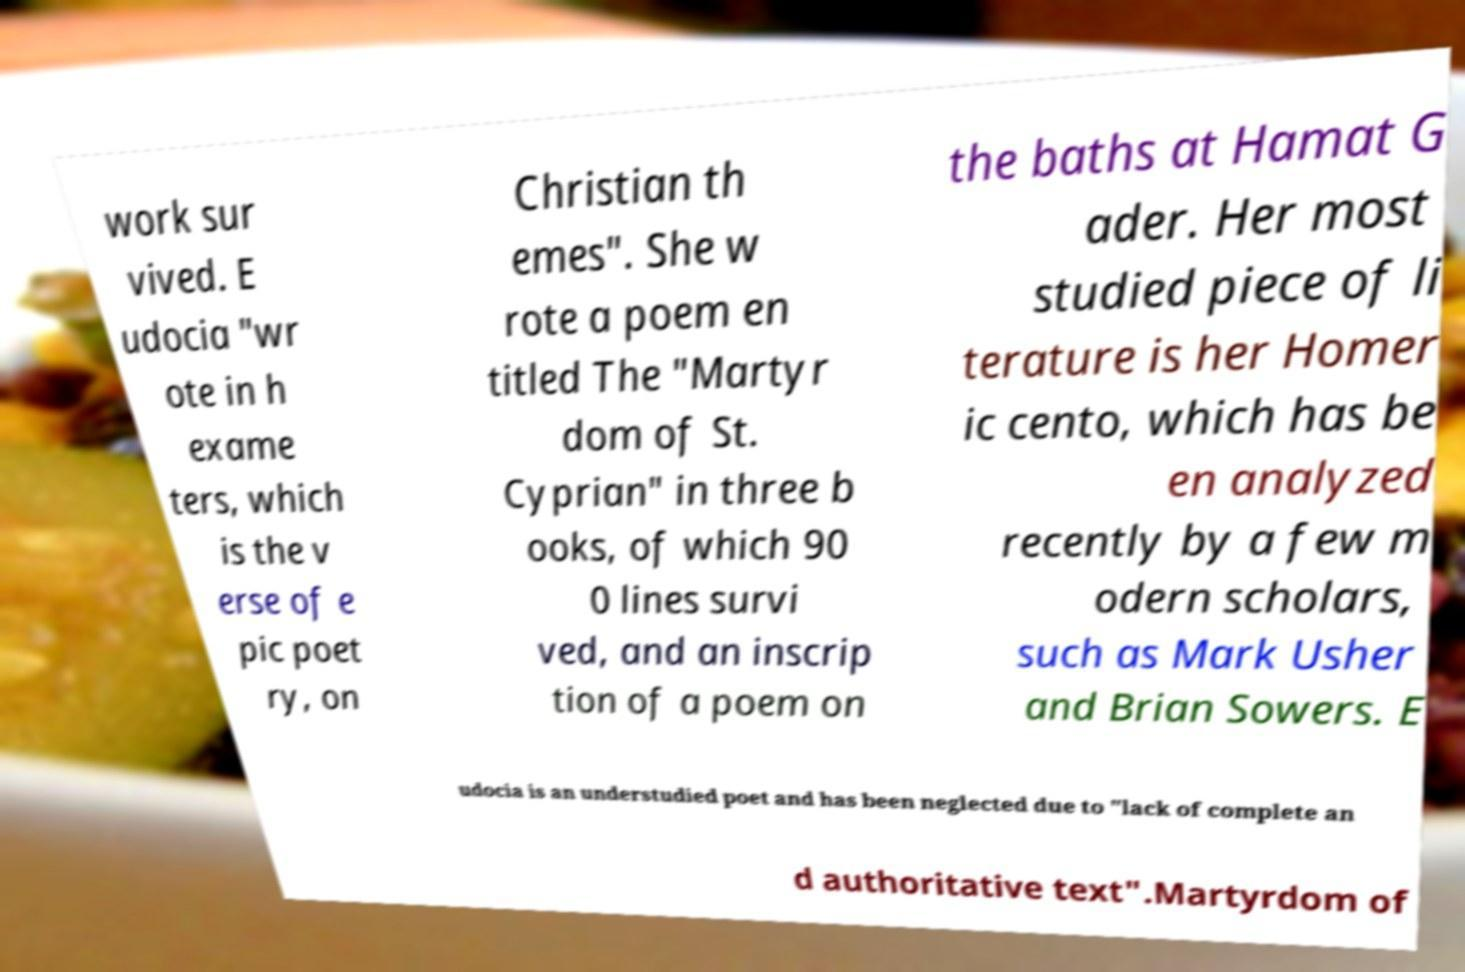Can you read and provide the text displayed in the image?This photo seems to have some interesting text. Can you extract and type it out for me? work sur vived. E udocia "wr ote in h exame ters, which is the v erse of e pic poet ry, on Christian th emes". She w rote a poem en titled The "Martyr dom of St. Cyprian" in three b ooks, of which 90 0 lines survi ved, and an inscrip tion of a poem on the baths at Hamat G ader. Her most studied piece of li terature is her Homer ic cento, which has be en analyzed recently by a few m odern scholars, such as Mark Usher and Brian Sowers. E udocia is an understudied poet and has been neglected due to "lack of complete an d authoritative text".Martyrdom of 